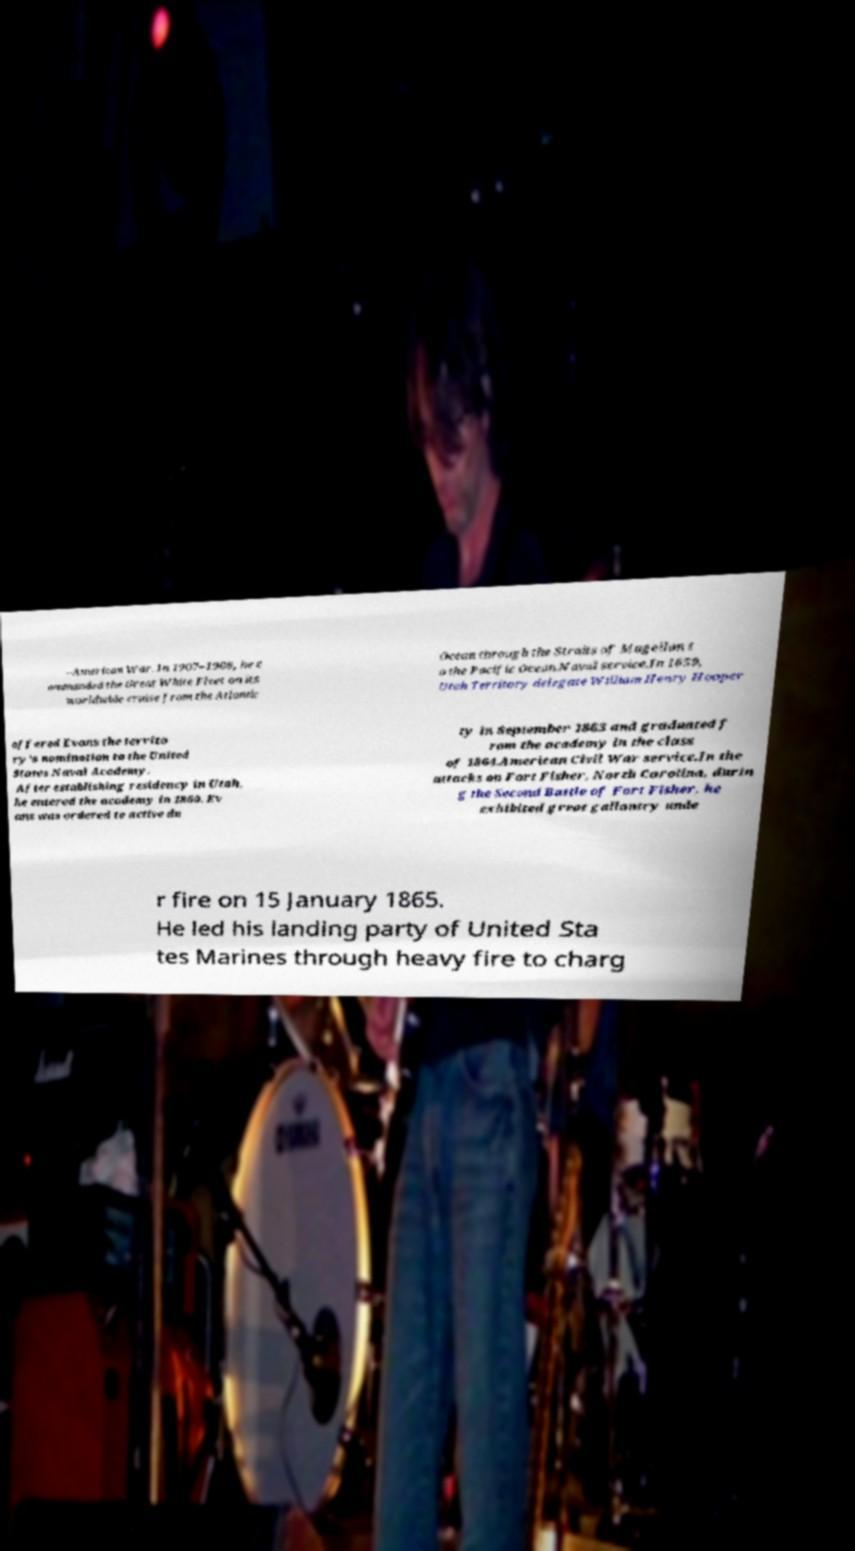Please read and relay the text visible in this image. What does it say? –American War. In 1907–1908, he c ommanded the Great White Fleet on its worldwide cruise from the Atlantic Ocean through the Straits of Magellan t o the Pacific Ocean.Naval service.In 1859, Utah Territory delegate William Henry Hooper offered Evans the territo ry's nomination to the United States Naval Academy. After establishing residency in Utah, he entered the academy in 1860. Ev ans was ordered to active du ty in September 1863 and graduated f rom the academy in the class of 1864.American Civil War service.In the attacks on Fort Fisher, North Carolina, durin g the Second Battle of Fort Fisher, he exhibited great gallantry unde r fire on 15 January 1865. He led his landing party of United Sta tes Marines through heavy fire to charg 